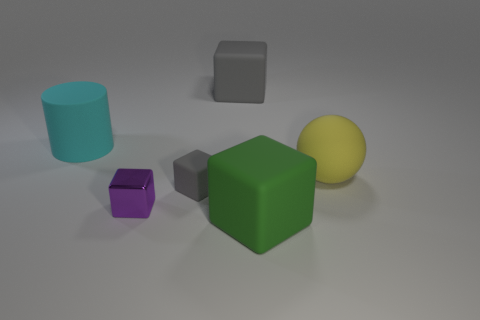Is the number of green matte things behind the big green cube greater than the number of small gray objects? Yes, the number of green matte objects behind the large green cube is indeed greater than the number of small gray objects. Upon observing the image, there is a single green cylindrical object behind the large green cube, while there are no small gray objects present, making the count of green matte objects higher. 